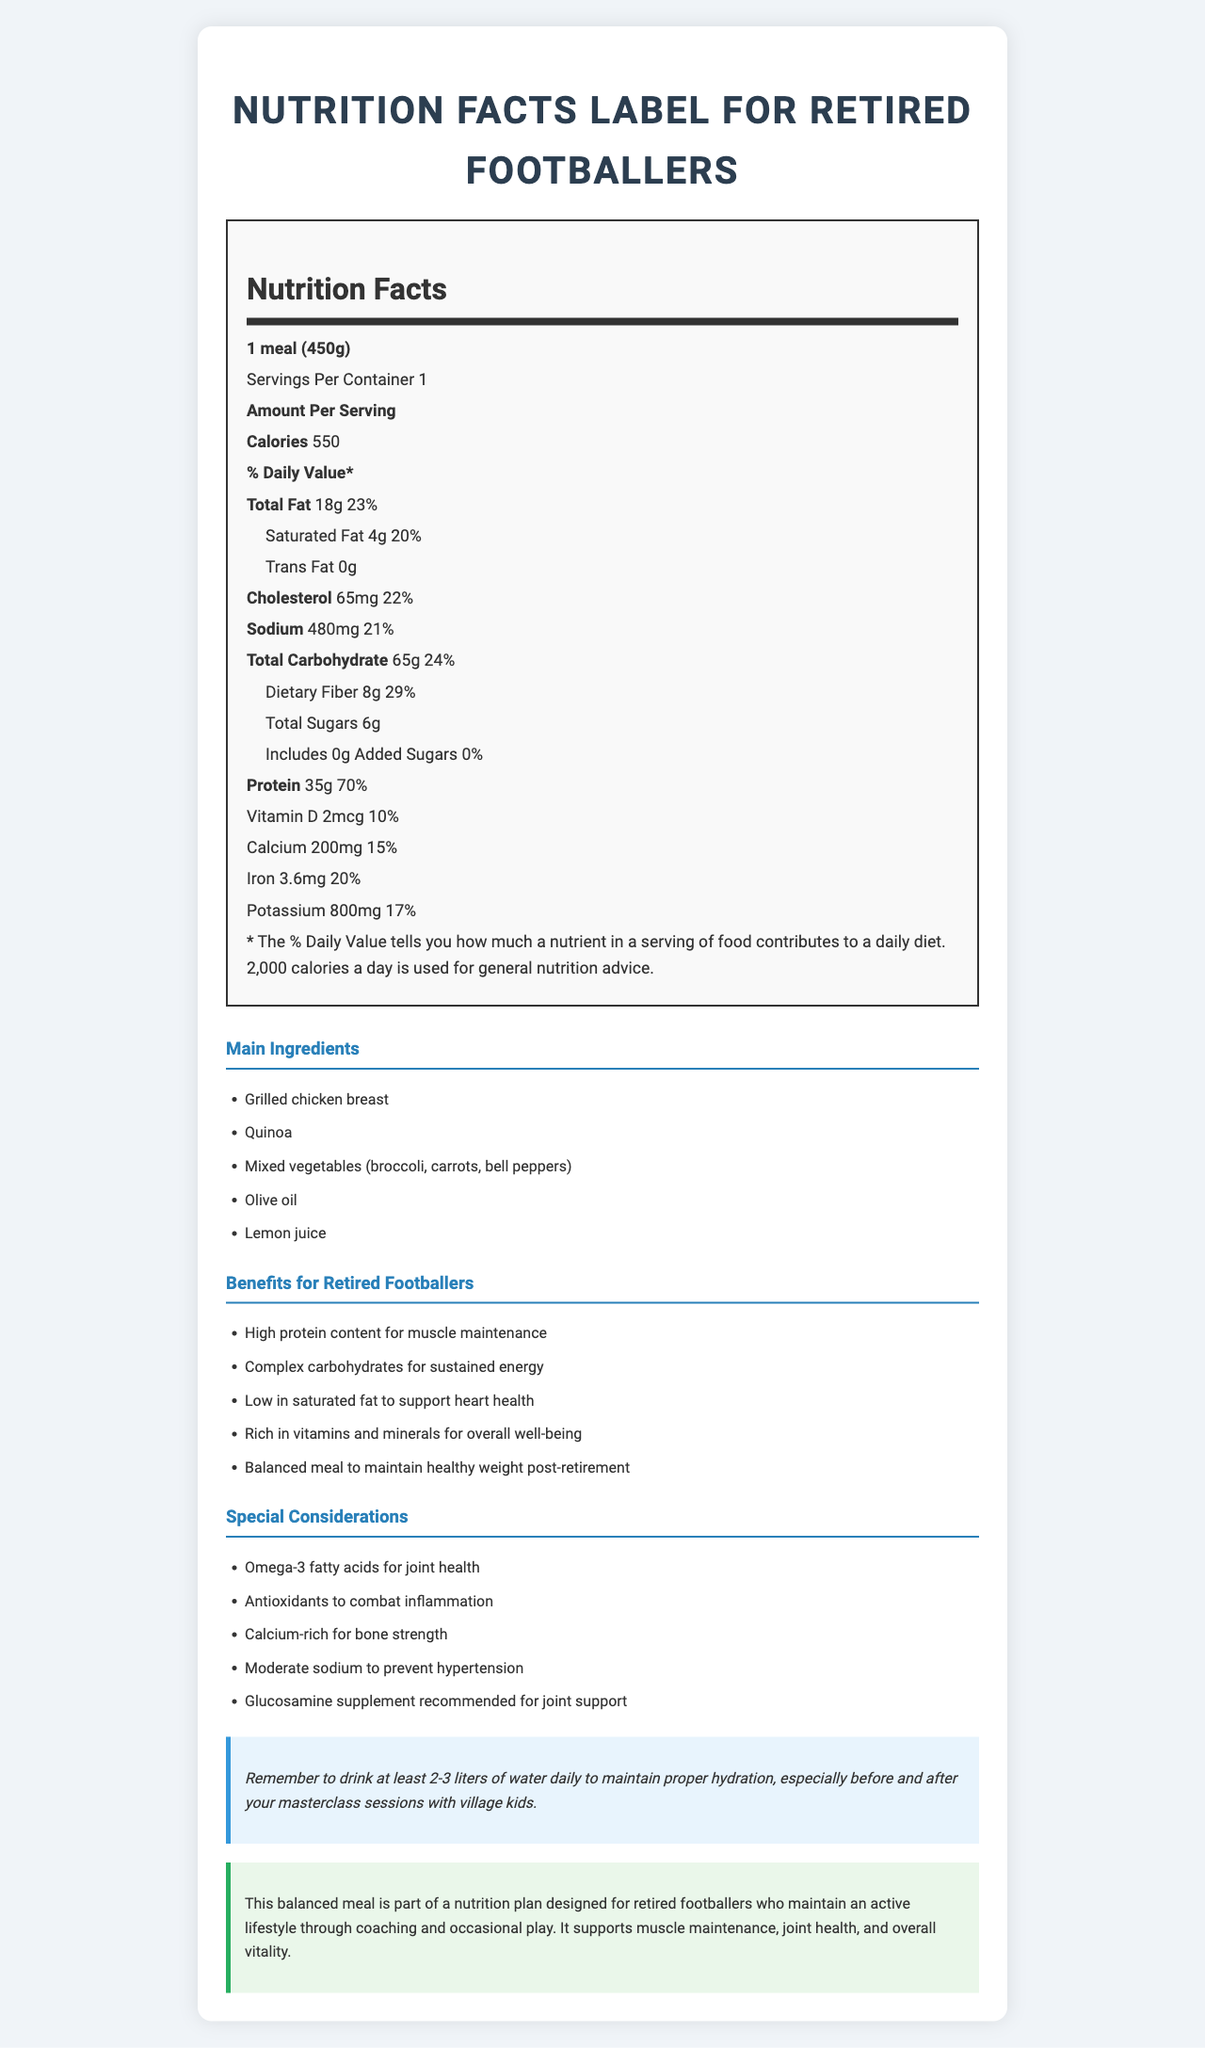what is the serving size of the meal? The serving size is listed at the beginning of the nutrition facts in the document.
Answer: 1 meal (450g) how many calories does one serving contain? The document specifies this under the 'Amount Per Serving' section.
Answer: 550 how much total fat is in one meal? The total fat content is mentioned in the nutrition facts under the 'Total Fat' section.
Answer: 18g what percentage of the daily value does the sodium content represent? The sodium content's daily value percentage is listed in the document.
Answer: 21% what are the main ingredients in the meal? The main ingredients are enumerated in the 'Main Ingredients' section of the document.
Answer: Grilled chicken breast, Quinoa, Mixed vegetables (broccoli, carrots, bell peppers), Olive oil, Lemon juice how much dietary fiber is in the meal? The dietary fiber content is indicated in the 'Total Carbohydrate' section of the nutrition facts.
Answer: 8g which vitamin has a daily value percentage of 15%? The daily value percentage of calcium is mentioned in the nutrition facts.
Answer: Calcium how much protein does the meal contain? The protein content is outlined in the 'Amount Per Serving' section.
Answer: 35g what should you remember to do for proper hydration? The hydration tip section of the document advises drinking at least 2-3 liters of water daily.
Answer: Drink at least 2-3 liters of water daily how many servings are there in one container? The document specifies that there is 1 serving per container.
Answer: 1 what is the amount of cholesterol in the meal? The amount of cholesterol is listed in the nutrition facts.
Answer: 65mg which of the following is NOT a main ingredient in the meal? A. Grilled chicken breast B. Quinoa C. Mixed vegetables D. Salmon Salmon is not listed in the main ingredients section, whereas the other options are.
Answer: D. Salmon the meal contains which of the following benefits for retired footballers? A. High protein content for muscle maintenance B. Low in saturated fat C. Rich in omega-3 fatty acids D. Balanced meal to maintain healthy weight post-retirement Option C is not listed under the footballer benefits section, whereas the other options are.
Answer: C. Rich in omega-3 fatty acids is the amount of trans fat in the meal greater than 0g? The document states that the trans fat content is 0g.
Answer: No summarize the purpose of this document. The document summarizes the nutritional make-up and its advantages for retired footballers, stressing muscle maintenance, joint health, and overall vitality, along with advice specific to a retired, yet active, lifestyle.
Answer: The document provides detailed nutrition information and benefits of a balanced meal plan tailored for retired footballers. It highlights the nutritional content of the meal, lists the main ingredients, describes the health benefits, and offers special considerations along with hydration tips for maintaining an active lifestyle through coaching and occasional play. what is the recommended supplement for joint support mentioned in the document? The document mentions that a Glucosamine supplement is recommended for joint support in the special considerations section.
Answer: Cannot be determined 